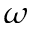<formula> <loc_0><loc_0><loc_500><loc_500>\omega</formula> 